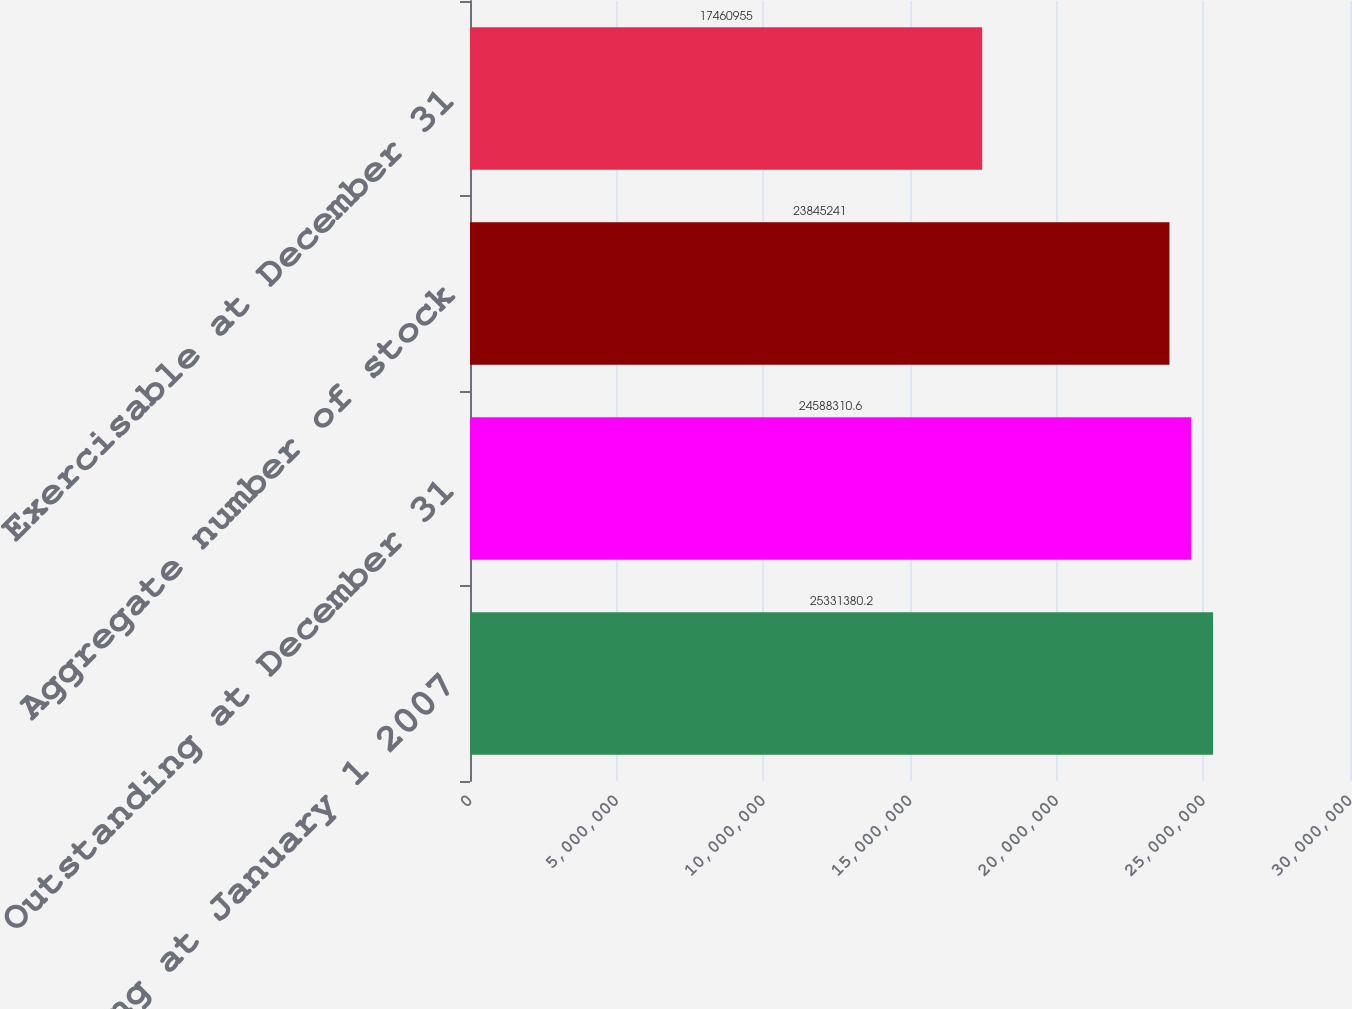<chart> <loc_0><loc_0><loc_500><loc_500><bar_chart><fcel>Outstanding at January 1 2007<fcel>Outstanding at December 31<fcel>Aggregate number of stock<fcel>Exercisable at December 31<nl><fcel>2.53314e+07<fcel>2.45883e+07<fcel>2.38452e+07<fcel>1.7461e+07<nl></chart> 